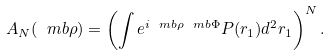Convert formula to latex. <formula><loc_0><loc_0><loc_500><loc_500>A _ { N } ( { \ m b \rho } ) = \left ( \int e ^ { i { \ m b \rho } { \ m b \Phi } } P ( { r } _ { 1 } ) d ^ { 2 } { r } _ { 1 } \right ) ^ { N } .</formula> 